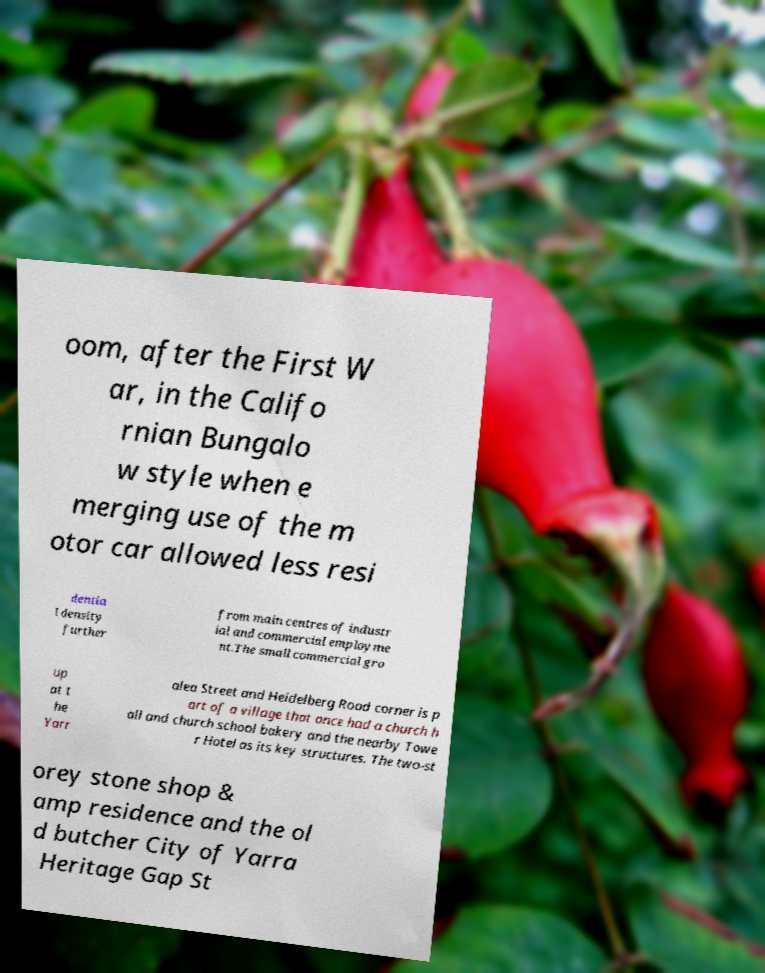Please read and relay the text visible in this image. What does it say? oom, after the First W ar, in the Califo rnian Bungalo w style when e merging use of the m otor car allowed less resi dentia l density further from main centres of industr ial and commercial employme nt.The small commercial gro up at t he Yarr alea Street and Heidelberg Road corner is p art of a village that once had a church h all and church school bakery and the nearby Towe r Hotel as its key structures. The two-st orey stone shop & amp residence and the ol d butcher City of Yarra Heritage Gap St 